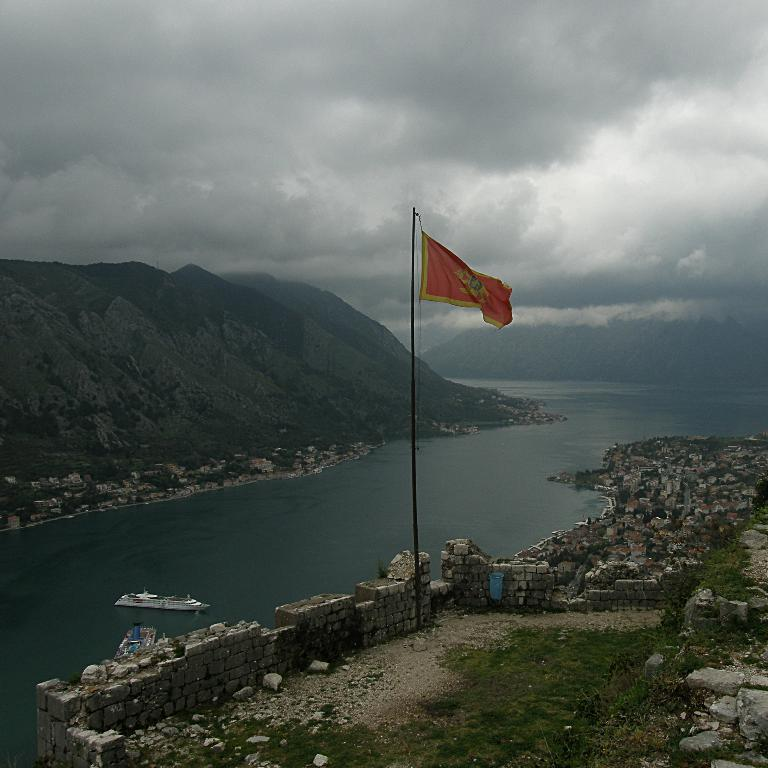What is the main subject in the middle of the image? There is a flag in the middle of the image. What can be seen on the left side of the image? There are boats on the water on the left side of the image. What type of natural scenery is visible in the background? There are trees, hills, and clouds present in the background. How many tramps are visible in the image? There are no tramps present in the image. What type of gun can be seen in the image? There is no gun present in the image. 